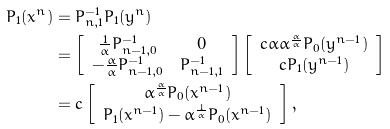Convert formula to latex. <formula><loc_0><loc_0><loc_500><loc_500>P _ { 1 } ( x ^ { n } ) & = P _ { n , 1 } ^ { - 1 } P _ { 1 } ( y ^ { n } ) \\ & = \left [ \begin{array} { c c } \frac { 1 } { \bar { \alpha } } P _ { n - 1 , 0 } ^ { - 1 } & 0 \\ - \frac { \alpha } { \bar { \alpha } } P _ { n - 1 , 0 } ^ { - 1 } & P _ { n - 1 , 1 } ^ { - 1 } \end{array} \right ] \left [ \begin{array} { c } c { \bar { \alpha } \alpha ^ { \frac { \alpha } { \bar { \alpha } } } } P _ { 0 } ( y ^ { n - 1 } ) \\ c P _ { 1 } ( y ^ { n - 1 } ) \end{array} \right ] \\ & = c \left [ \begin{array} { c } { \alpha ^ { \frac { \alpha } { \bar { \alpha } } } } P _ { 0 } ( x ^ { n - 1 } ) \\ P _ { 1 } ( x ^ { n - 1 } ) - { \alpha ^ { \frac { 1 } { \bar { \alpha } } } } P _ { 0 } ( x ^ { n - 1 } ) \end{array} \right ] ,</formula> 